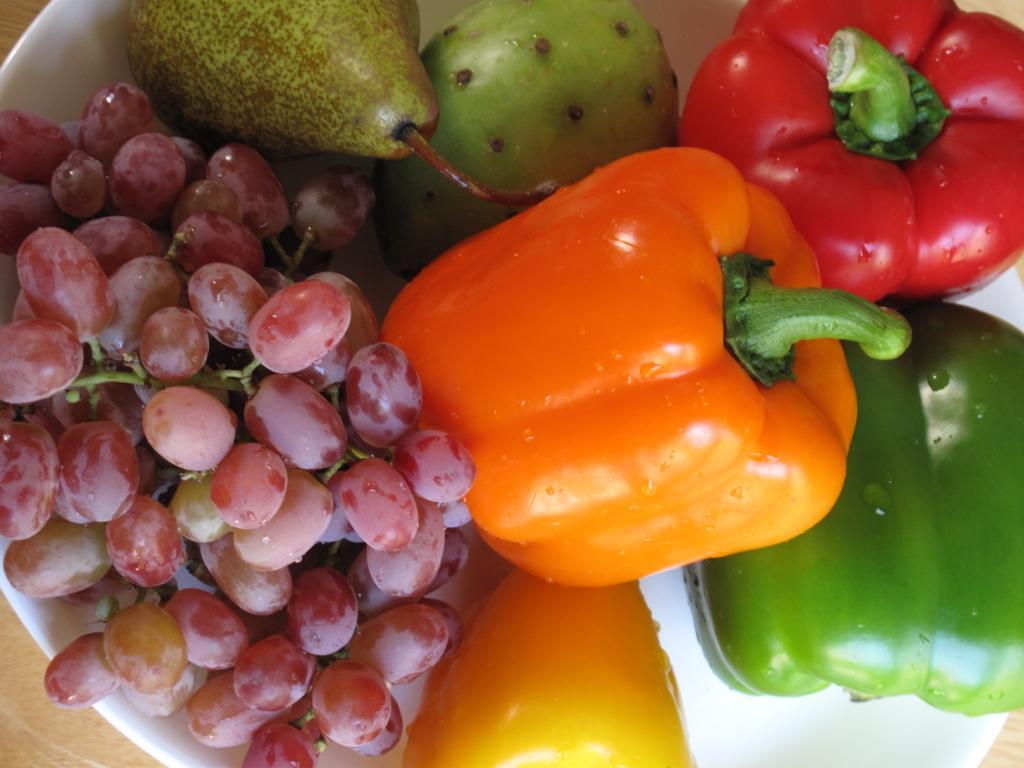In one or two sentences, can you explain what this image depicts? In this image I can see a white colored bowl and in the bowl I can see few grapes, few capsicums which are orange, red and green in color and few other fruits which are green in color. 